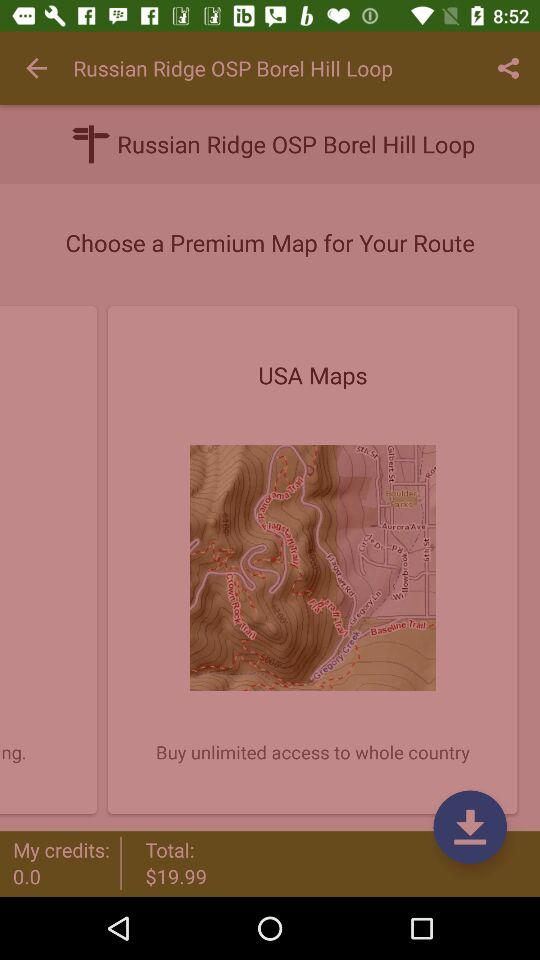What is the total price? The total price is $19.99. 